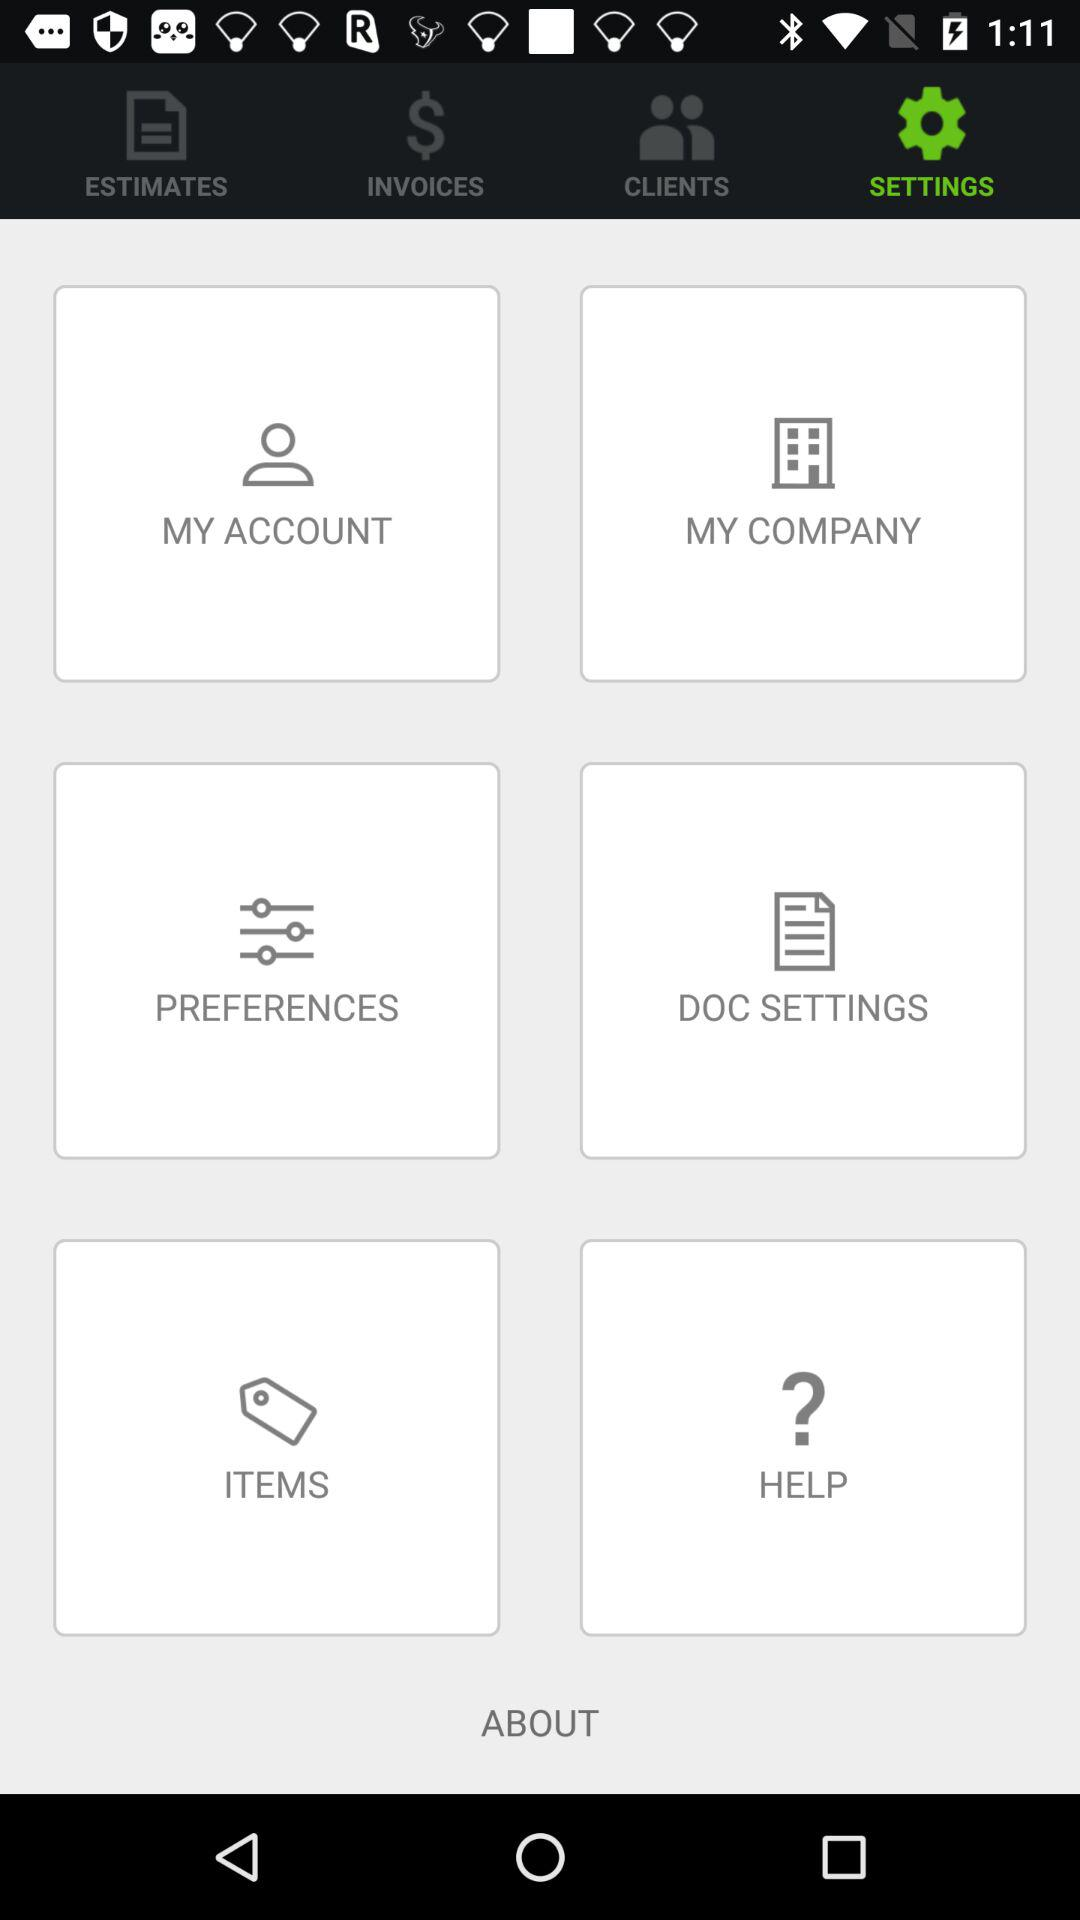Which option is selected? The selected option is "SETTINGS". 